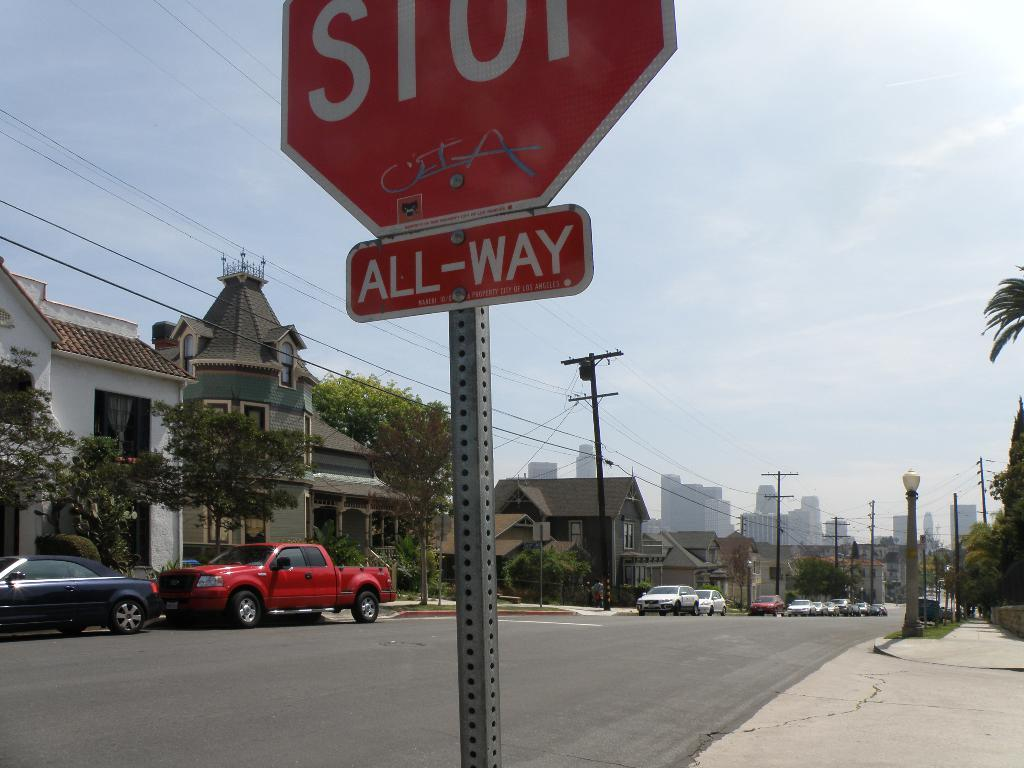<image>
Relay a brief, clear account of the picture shown. a stop sign with a few cars around the area 